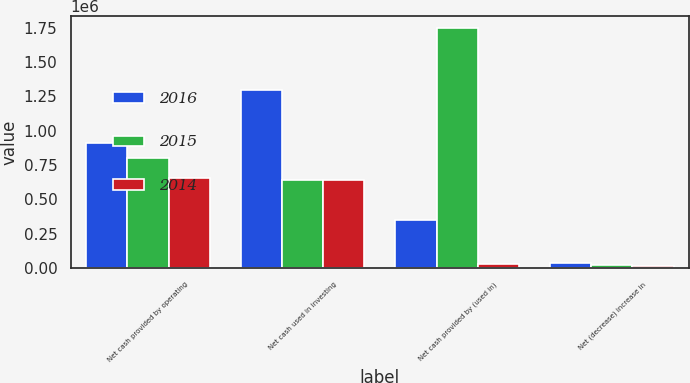<chart> <loc_0><loc_0><loc_500><loc_500><stacked_bar_chart><ecel><fcel>Net cash provided by operating<fcel>Net cash used in investing<fcel>Net cash provided by (used in)<fcel>Net (decrease) increase in<nl><fcel>2016<fcel>912262<fcel>1.29943e+06<fcel>351931<fcel>35238<nl><fcel>2015<fcel>799232<fcel>644180<fcel>1.74903e+06<fcel>22239<nl><fcel>2014<fcel>655888<fcel>644180<fcel>26974<fcel>15266<nl></chart> 